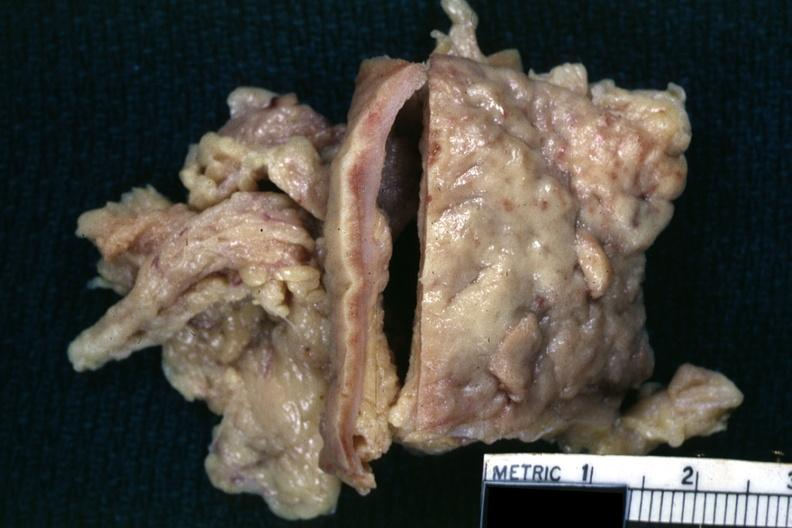where is this area in the body?
Answer the question using a single word or phrase. Abdomen 